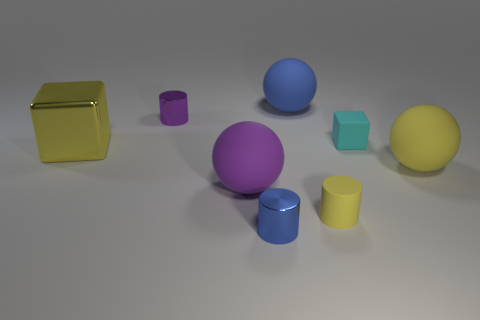Add 1 big blue rubber objects. How many objects exist? 9 Subtract all cylinders. How many objects are left? 5 Subtract all big rubber objects. Subtract all green metal cubes. How many objects are left? 5 Add 4 yellow objects. How many yellow objects are left? 7 Add 7 purple metal cylinders. How many purple metal cylinders exist? 8 Subtract 1 cyan cubes. How many objects are left? 7 